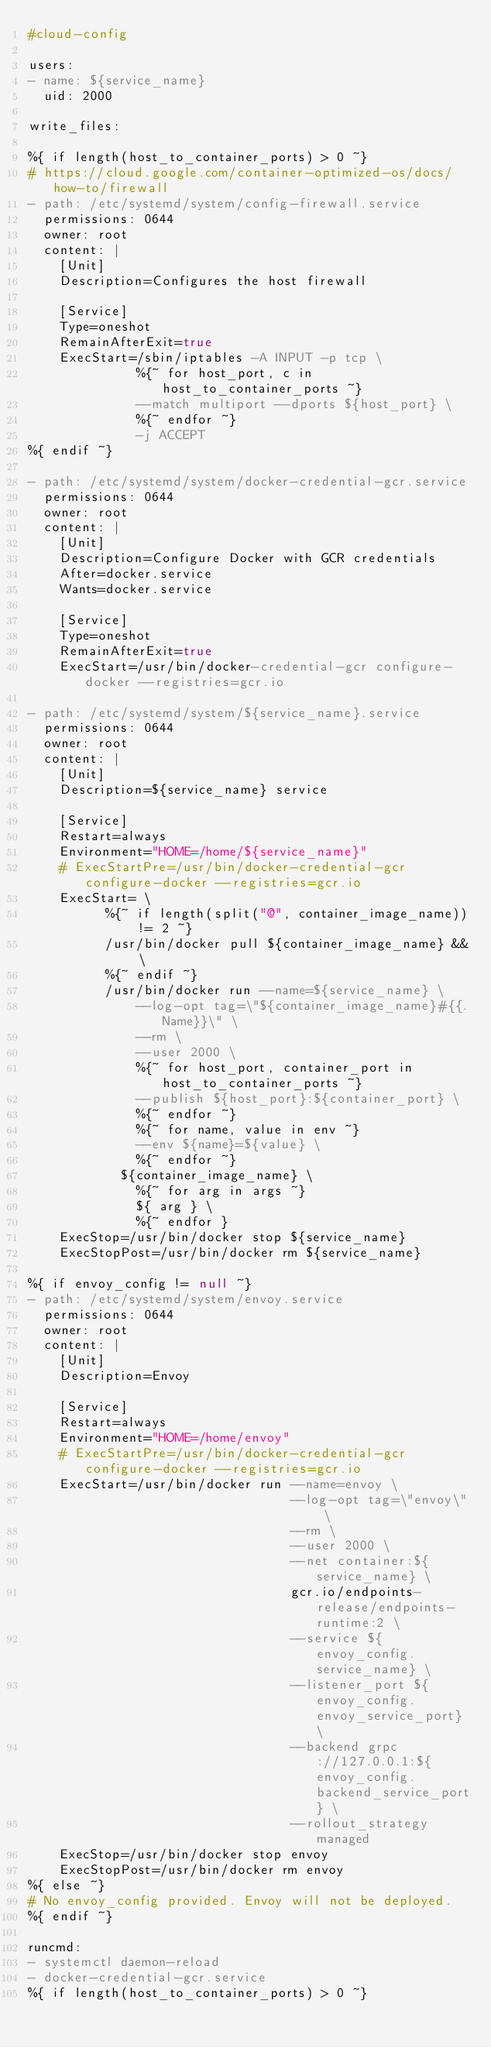Convert code to text. <code><loc_0><loc_0><loc_500><loc_500><_YAML_>#cloud-config

users:
- name: ${service_name}
  uid: 2000

write_files:

%{ if length(host_to_container_ports) > 0 ~}
# https://cloud.google.com/container-optimized-os/docs/how-to/firewall
- path: /etc/systemd/system/config-firewall.service
  permissions: 0644
  owner: root
  content: |
    [Unit]
    Description=Configures the host firewall

    [Service]
    Type=oneshot
    RemainAfterExit=true
    ExecStart=/sbin/iptables -A INPUT -p tcp \
              %{~ for host_port, c in host_to_container_ports ~}
              --match multiport --dports ${host_port} \
              %{~ endfor ~}
              -j ACCEPT
%{ endif ~}

- path: /etc/systemd/system/docker-credential-gcr.service
  permissions: 0644
  owner: root
  content: |
    [Unit]
    Description=Configure Docker with GCR credentials
    After=docker.service
    Wants=docker.service

    [Service]
    Type=oneshot
    RemainAfterExit=true
    ExecStart=/usr/bin/docker-credential-gcr configure-docker --registries=gcr.io

- path: /etc/systemd/system/${service_name}.service
  permissions: 0644
  owner: root
  content: |
    [Unit]
    Description=${service_name} service

    [Service]
    Restart=always
    Environment="HOME=/home/${service_name}"
    # ExecStartPre=/usr/bin/docker-credential-gcr configure-docker --registries=gcr.io
    ExecStart= \
          %{~ if length(split("@", container_image_name)) != 2 ~}
          /usr/bin/docker pull ${container_image_name} && \
          %{~ endif ~}
          /usr/bin/docker run --name=${service_name} \
              --log-opt tag=\"${container_image_name}#{{.Name}}\" \
              --rm \
              --user 2000 \
              %{~ for host_port, container_port in host_to_container_ports ~}
              --publish ${host_port}:${container_port} \
              %{~ endfor ~}
              %{~ for name, value in env ~}
              --env ${name}=${value} \
              %{~ endfor ~}
            ${container_image_name} \
              %{~ for arg in args ~}
              ${ arg } \
              %{~ endfor }
    ExecStop=/usr/bin/docker stop ${service_name}
    ExecStopPost=/usr/bin/docker rm ${service_name}

%{ if envoy_config != null ~}
- path: /etc/systemd/system/envoy.service
  permissions: 0644
  owner: root
  content: |
    [Unit]
    Description=Envoy

    [Service]
    Restart=always
    Environment="HOME=/home/envoy"
    # ExecStartPre=/usr/bin/docker-credential-gcr configure-docker --registries=gcr.io
    ExecStart=/usr/bin/docker run --name=envoy \
                                  --log-opt tag=\"envoy\" \
                                  --rm \
                                  --user 2000 \
                                  --net container:${service_name} \
                                  gcr.io/endpoints-release/endpoints-runtime:2 \
                                  --service ${envoy_config.service_name} \
                                  --listener_port ${envoy_config.envoy_service_port} \
                                  --backend grpc://127.0.0.1:${envoy_config.backend_service_port} \
                                  --rollout_strategy managed
    ExecStop=/usr/bin/docker stop envoy
    ExecStopPost=/usr/bin/docker rm envoy
%{ else ~}
# No envoy_config provided. Envoy will not be deployed.
%{ endif ~}

runcmd:
- systemctl daemon-reload
- docker-credential-gcr.service
%{ if length(host_to_container_ports) > 0 ~}</code> 